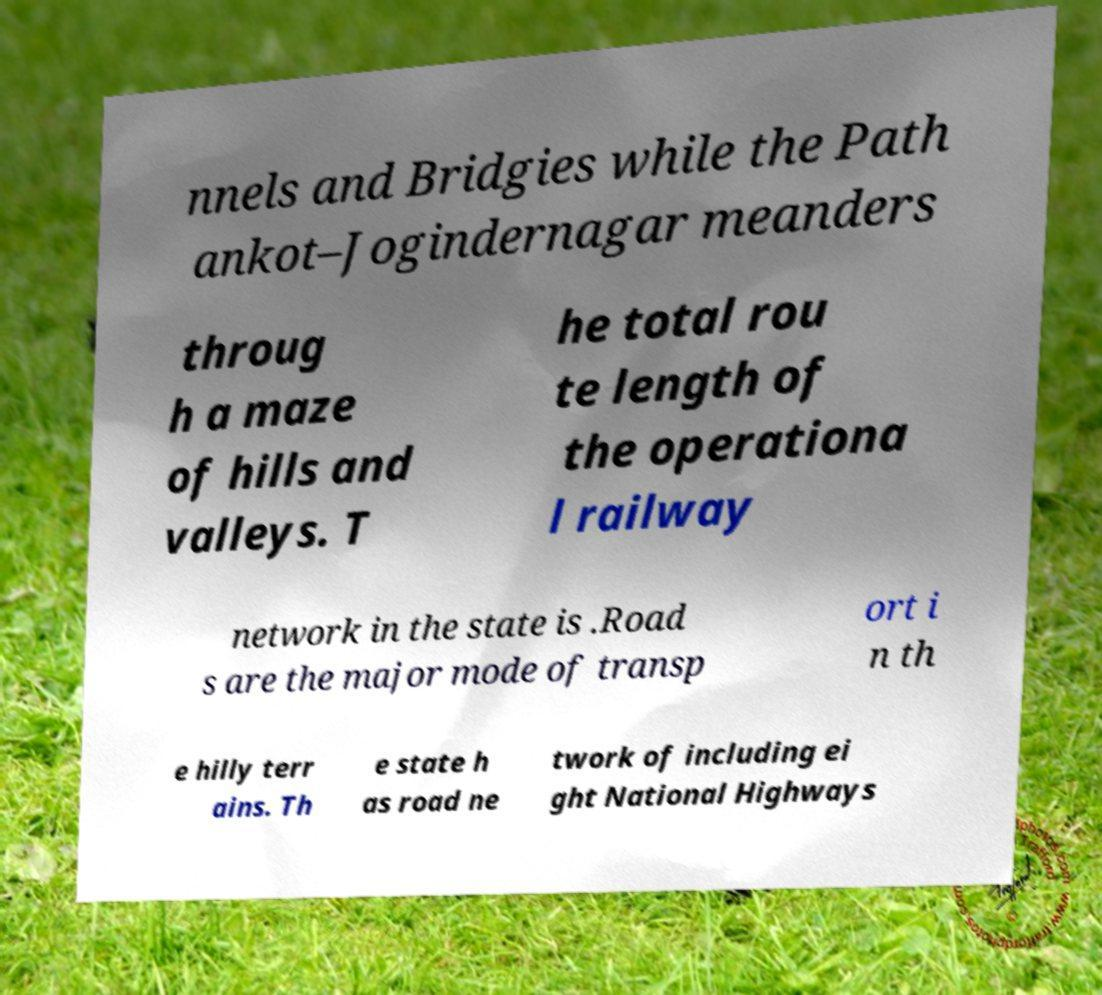Please read and relay the text visible in this image. What does it say? nnels and Bridgies while the Path ankot–Jogindernagar meanders throug h a maze of hills and valleys. T he total rou te length of the operationa l railway network in the state is .Road s are the major mode of transp ort i n th e hilly terr ains. Th e state h as road ne twork of including ei ght National Highways 